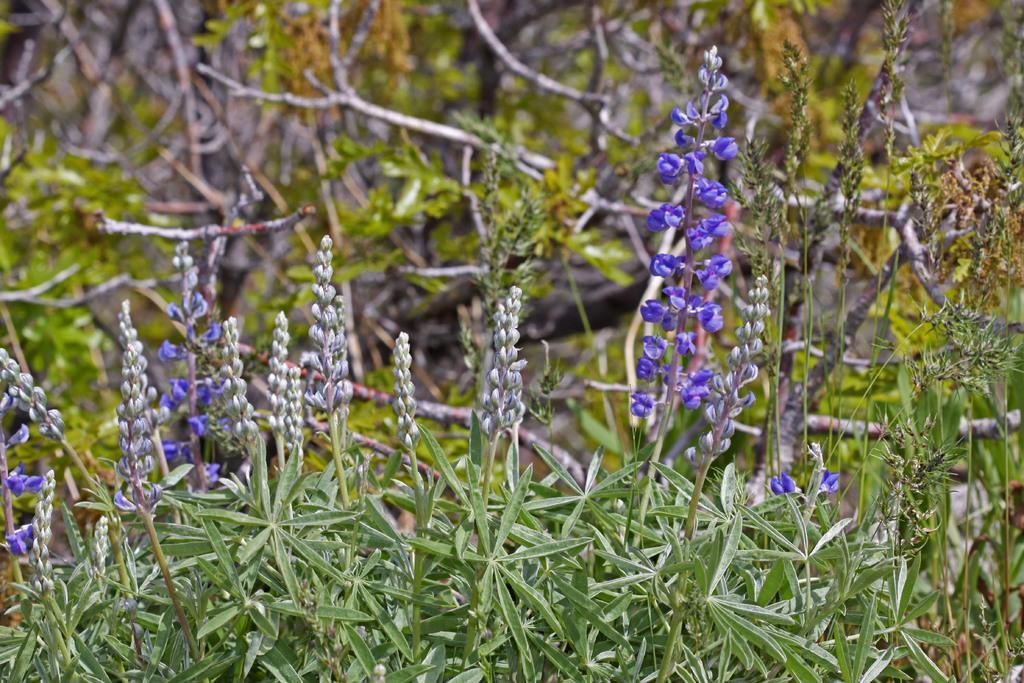Describe this image in one or two sentences. Here we can see plants with violet color flowers and in the background there are trees. 